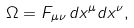Convert formula to latex. <formula><loc_0><loc_0><loc_500><loc_500>\Omega = F _ { \mu \nu } \, d x ^ { \mu } d x ^ { \nu } ,</formula> 